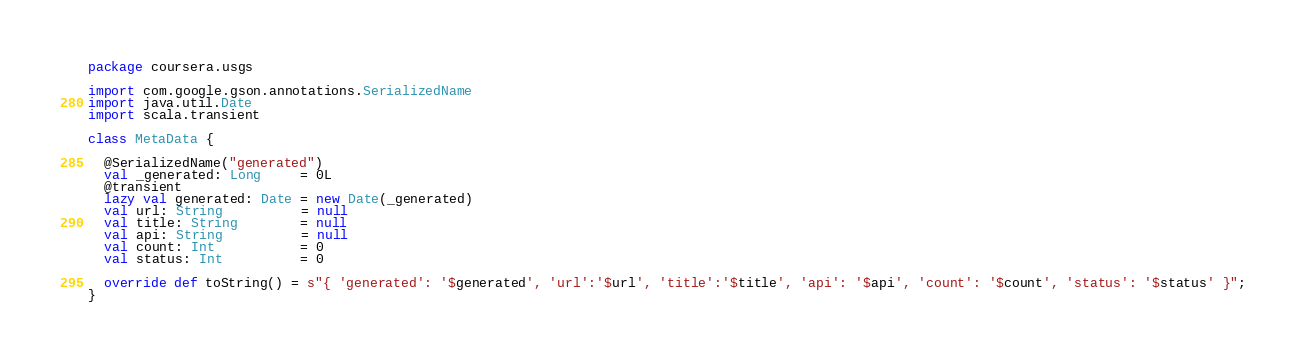Convert code to text. <code><loc_0><loc_0><loc_500><loc_500><_Scala_>package coursera.usgs

import com.google.gson.annotations.SerializedName
import java.util.Date
import scala.transient

class MetaData {

  @SerializedName("generated")
  val _generated: Long     = 0L
  @transient
  lazy val generated: Date = new Date(_generated)
  val url: String          = null
  val title: String        = null
  val api: String          = null
  val count: Int           = 0
  val status: Int          = 0

  override def toString() = s"{ 'generated': '$generated', 'url':'$url', 'title':'$title', 'api': '$api', 'count': '$count', 'status': '$status' }";
}
</code> 